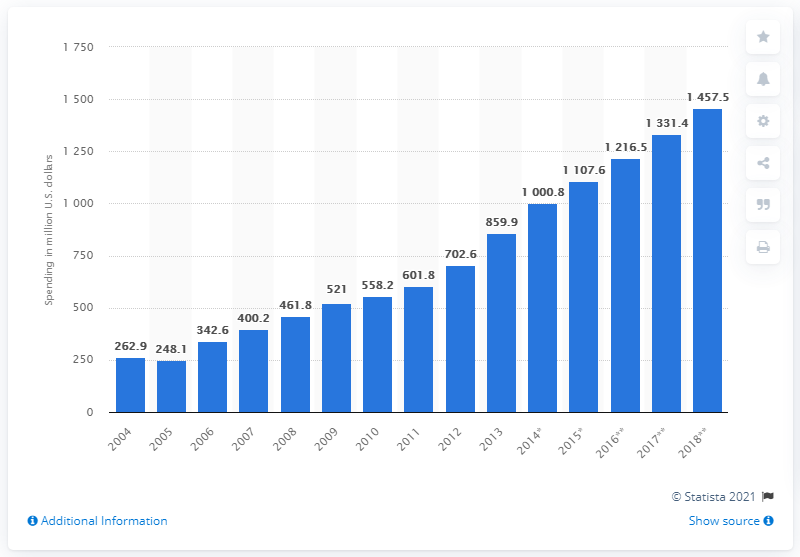Indicate a few pertinent items in this graphic. By 2018, it is projected that the amount of advertising spend in Vietnam will be approximately 1457.5. In 2016, the estimated amount of ad expenditure in Vietnam was 1216.5. 